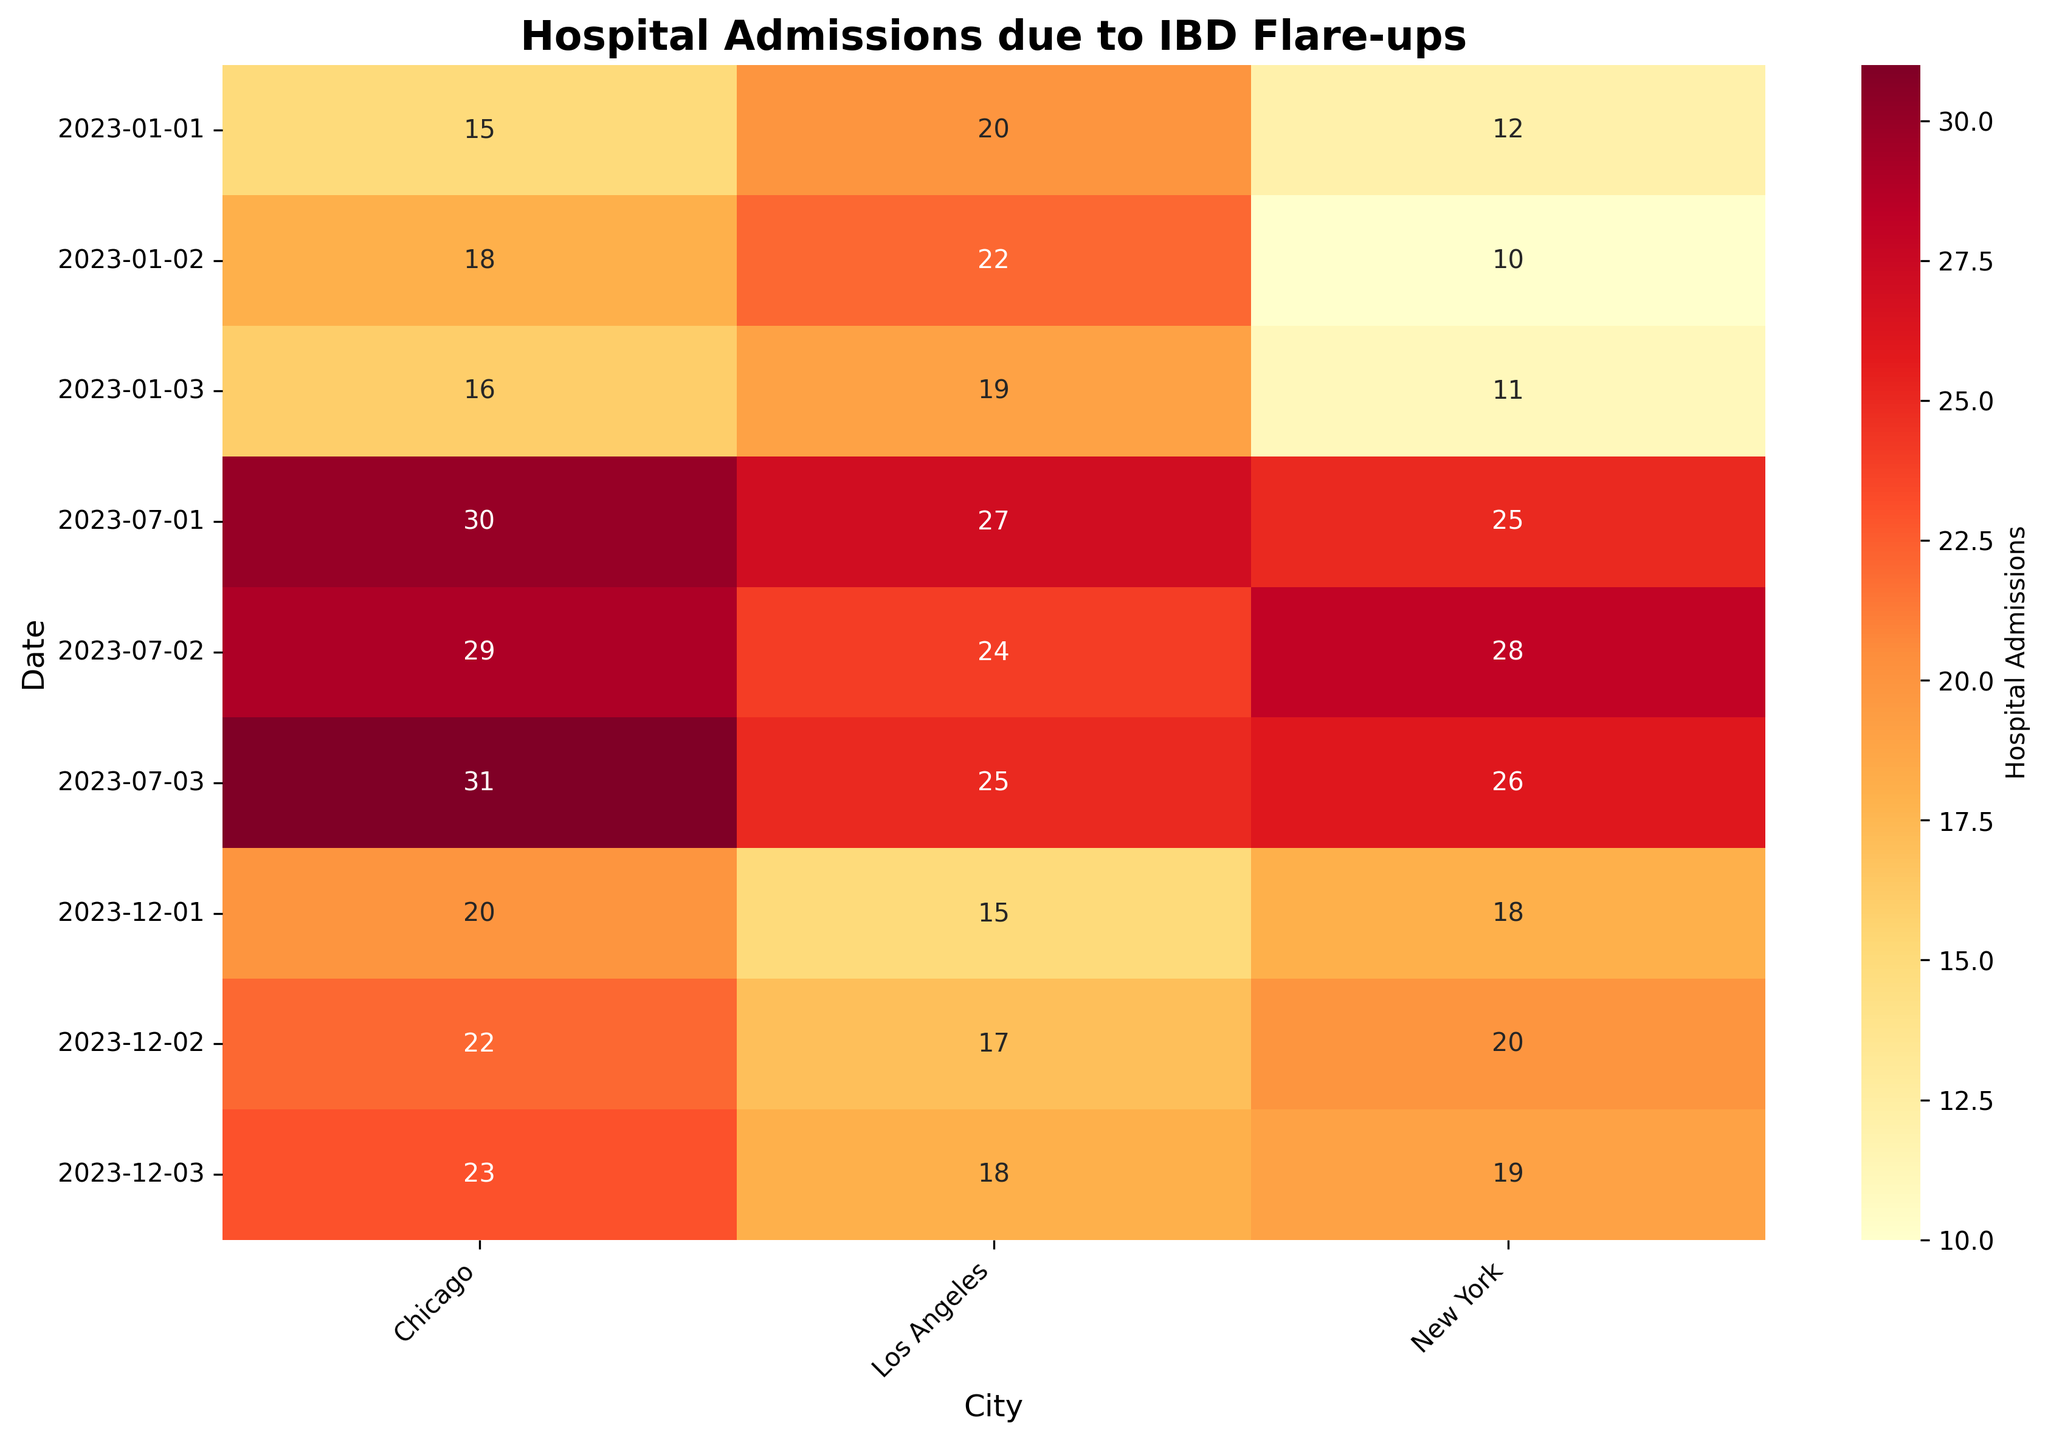What's the title of the heatmap? The title is shown at the top center of the heatmap and typically summarizes the main idea or focus of the plot. Here, the title is "Hospital Admissions due to IBD Flare-ups."
Answer: Hospital Admissions due to IBD Flare-ups Which city had the highest number of hospital admissions on July 3, 2023? To find this, locate July 3, 2023, on the Y-axis and then look across the corresponding row. Compare the numbers for New York, Los Angeles, and Chicago. The highest number in that row is in the Chicago column, with 31 admissions.
Answer: Chicago How many hospital admissions were recorded in New York on January 1, 2023? Find the row for January 1, 2023, on the Y-axis, and then look at the cell under the New York column. The number of hospital admissions recorded is 12.
Answer: 12 Which date in December 2023 had the lowest number of hospital admissions in Los Angeles? Focus on the December 2023 part of the Y-axis and compare the numbers in the Los Angeles column for each of the dates. The lowest number is 15, which is on December 1, 2023.
Answer: December 1, 2023 What is the average number of hospital admissions in Chicago for the dates provided in January 2023? Sum the hospital admissions for Chicago in January 2023 (15 + 18 + 16 = 49) and divide by the number of days (3). This gives an average of 49/3 = 16.33.
Answer: 16.33 Compare the hospital admissions in New York on January 1, 2023, and July 1, 2023. Which is higher, and by how much? Look at the number of admissions in New York for both dates. January 1, 2023, has 12 admissions, while July 1, 2023, has 25 admissions. The difference is 25 - 12 = 13.
Answer: July 1, by 13 Which city showed the most fluctuation in hospital admissions between July 1 and July 3, 2023? Calculate the range of admissions for each city by subtracting the minimum from the maximum between those dates. New York: 28 - 25 = 3; Los Angeles: 25 - 24 = 1; Chicago: 31 - 29 = 2. New York has the highest fluctuation.
Answer: New York Among the cities listed, which had the highest number of hospital admissions on January 2, 2023? Locate January 2, 2023, on the Y-axis and then compare the numbers for each city. Los Angeles has the highest number with 22 admissions.
Answer: Los Angeles On December 3, 2023, what is the total number of hospital admissions across all three cities? Add the hospital admissions for New York, Los Angeles, and Chicago on December 3, 2023 (19 + 18 + 23). The total is 19 + 18 + 23 = 60.
Answer: 60 